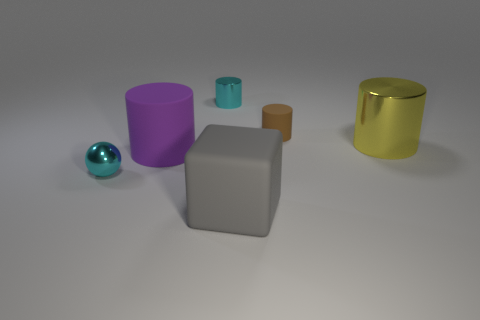Subtract all cyan metallic cylinders. How many cylinders are left? 3 Subtract all brown cylinders. How many cylinders are left? 3 Add 2 tiny matte things. How many objects exist? 8 Subtract all spheres. How many objects are left? 5 Subtract all gray cylinders. Subtract all green blocks. How many cylinders are left? 4 Add 3 objects. How many objects exist? 9 Subtract 0 red blocks. How many objects are left? 6 Subtract 1 blocks. How many blocks are left? 0 Subtract all brown blocks. How many red cylinders are left? 0 Subtract all cyan metal things. Subtract all small brown cylinders. How many objects are left? 3 